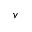Convert formula to latex. <formula><loc_0><loc_0><loc_500><loc_500>v</formula> 